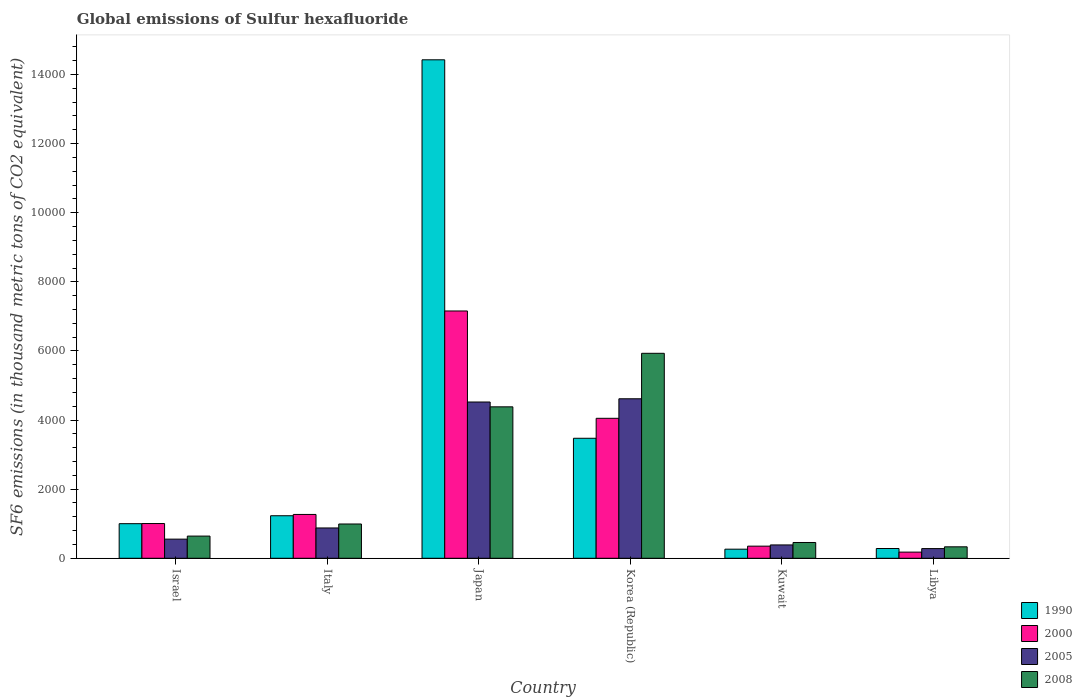How many different coloured bars are there?
Your answer should be compact. 4. How many groups of bars are there?
Give a very brief answer. 6. Are the number of bars per tick equal to the number of legend labels?
Give a very brief answer. Yes. Are the number of bars on each tick of the X-axis equal?
Offer a terse response. Yes. How many bars are there on the 1st tick from the left?
Your answer should be very brief. 4. What is the label of the 5th group of bars from the left?
Provide a short and direct response. Kuwait. What is the global emissions of Sulfur hexafluoride in 2000 in Japan?
Keep it short and to the point. 7156.6. Across all countries, what is the maximum global emissions of Sulfur hexafluoride in 2008?
Offer a very short reply. 5931.6. Across all countries, what is the minimum global emissions of Sulfur hexafluoride in 1990?
Provide a short and direct response. 263. In which country was the global emissions of Sulfur hexafluoride in 1990 minimum?
Ensure brevity in your answer.  Kuwait. What is the total global emissions of Sulfur hexafluoride in 2008 in the graph?
Give a very brief answer. 1.27e+04. What is the difference between the global emissions of Sulfur hexafluoride in 1990 in Israel and that in Japan?
Provide a succinct answer. -1.34e+04. What is the difference between the global emissions of Sulfur hexafluoride in 2005 in Japan and the global emissions of Sulfur hexafluoride in 2008 in Kuwait?
Your response must be concise. 4065.9. What is the average global emissions of Sulfur hexafluoride in 2008 per country?
Provide a short and direct response. 2122.72. What is the difference between the global emissions of Sulfur hexafluoride of/in 2000 and global emissions of Sulfur hexafluoride of/in 1990 in Korea (Republic)?
Offer a terse response. 577.6. In how many countries, is the global emissions of Sulfur hexafluoride in 1990 greater than 7600 thousand metric tons?
Provide a succinct answer. 1. What is the ratio of the global emissions of Sulfur hexafluoride in 2008 in Italy to that in Libya?
Offer a very short reply. 2.99. Is the difference between the global emissions of Sulfur hexafluoride in 2000 in Japan and Korea (Republic) greater than the difference between the global emissions of Sulfur hexafluoride in 1990 in Japan and Korea (Republic)?
Your response must be concise. No. What is the difference between the highest and the second highest global emissions of Sulfur hexafluoride in 2000?
Your answer should be very brief. -3106.1. What is the difference between the highest and the lowest global emissions of Sulfur hexafluoride in 2008?
Your answer should be compact. 5600.1. In how many countries, is the global emissions of Sulfur hexafluoride in 2000 greater than the average global emissions of Sulfur hexafluoride in 2000 taken over all countries?
Make the answer very short. 2. Is the sum of the global emissions of Sulfur hexafluoride in 2000 in Israel and Japan greater than the maximum global emissions of Sulfur hexafluoride in 2008 across all countries?
Provide a succinct answer. Yes. Is it the case that in every country, the sum of the global emissions of Sulfur hexafluoride in 1990 and global emissions of Sulfur hexafluoride in 2008 is greater than the sum of global emissions of Sulfur hexafluoride in 2005 and global emissions of Sulfur hexafluoride in 2000?
Offer a very short reply. No. What does the 3rd bar from the left in Italy represents?
Provide a short and direct response. 2005. Is it the case that in every country, the sum of the global emissions of Sulfur hexafluoride in 2000 and global emissions of Sulfur hexafluoride in 2008 is greater than the global emissions of Sulfur hexafluoride in 1990?
Offer a terse response. No. How many countries are there in the graph?
Give a very brief answer. 6. Are the values on the major ticks of Y-axis written in scientific E-notation?
Ensure brevity in your answer.  No. Where does the legend appear in the graph?
Give a very brief answer. Bottom right. How many legend labels are there?
Ensure brevity in your answer.  4. What is the title of the graph?
Provide a succinct answer. Global emissions of Sulfur hexafluoride. Does "1981" appear as one of the legend labels in the graph?
Your answer should be compact. No. What is the label or title of the X-axis?
Your answer should be very brief. Country. What is the label or title of the Y-axis?
Keep it short and to the point. SF6 emissions (in thousand metric tons of CO2 equivalent). What is the SF6 emissions (in thousand metric tons of CO2 equivalent) of 1990 in Israel?
Make the answer very short. 1001. What is the SF6 emissions (in thousand metric tons of CO2 equivalent) of 2000 in Israel?
Keep it short and to the point. 1005.2. What is the SF6 emissions (in thousand metric tons of CO2 equivalent) in 2005 in Israel?
Provide a succinct answer. 553.7. What is the SF6 emissions (in thousand metric tons of CO2 equivalent) in 2008 in Israel?
Make the answer very short. 642. What is the SF6 emissions (in thousand metric tons of CO2 equivalent) of 1990 in Italy?
Offer a very short reply. 1230.8. What is the SF6 emissions (in thousand metric tons of CO2 equivalent) in 2000 in Italy?
Your response must be concise. 1268.5. What is the SF6 emissions (in thousand metric tons of CO2 equivalent) in 2005 in Italy?
Offer a very short reply. 877.2. What is the SF6 emissions (in thousand metric tons of CO2 equivalent) of 2008 in Italy?
Ensure brevity in your answer.  992.1. What is the SF6 emissions (in thousand metric tons of CO2 equivalent) of 1990 in Japan?
Offer a very short reply. 1.44e+04. What is the SF6 emissions (in thousand metric tons of CO2 equivalent) of 2000 in Japan?
Your answer should be very brief. 7156.6. What is the SF6 emissions (in thousand metric tons of CO2 equivalent) of 2005 in Japan?
Keep it short and to the point. 4522.3. What is the SF6 emissions (in thousand metric tons of CO2 equivalent) in 2008 in Japan?
Your response must be concise. 4382.7. What is the SF6 emissions (in thousand metric tons of CO2 equivalent) of 1990 in Korea (Republic)?
Your response must be concise. 3472.9. What is the SF6 emissions (in thousand metric tons of CO2 equivalent) in 2000 in Korea (Republic)?
Offer a terse response. 4050.5. What is the SF6 emissions (in thousand metric tons of CO2 equivalent) of 2005 in Korea (Republic)?
Keep it short and to the point. 4615.7. What is the SF6 emissions (in thousand metric tons of CO2 equivalent) of 2008 in Korea (Republic)?
Ensure brevity in your answer.  5931.6. What is the SF6 emissions (in thousand metric tons of CO2 equivalent) of 1990 in Kuwait?
Ensure brevity in your answer.  263. What is the SF6 emissions (in thousand metric tons of CO2 equivalent) in 2000 in Kuwait?
Your response must be concise. 350.9. What is the SF6 emissions (in thousand metric tons of CO2 equivalent) in 2005 in Kuwait?
Give a very brief answer. 386. What is the SF6 emissions (in thousand metric tons of CO2 equivalent) in 2008 in Kuwait?
Make the answer very short. 456.4. What is the SF6 emissions (in thousand metric tons of CO2 equivalent) of 1990 in Libya?
Give a very brief answer. 282.4. What is the SF6 emissions (in thousand metric tons of CO2 equivalent) in 2000 in Libya?
Provide a succinct answer. 178.2. What is the SF6 emissions (in thousand metric tons of CO2 equivalent) in 2005 in Libya?
Make the answer very short. 280.3. What is the SF6 emissions (in thousand metric tons of CO2 equivalent) in 2008 in Libya?
Give a very brief answer. 331.5. Across all countries, what is the maximum SF6 emissions (in thousand metric tons of CO2 equivalent) in 1990?
Offer a terse response. 1.44e+04. Across all countries, what is the maximum SF6 emissions (in thousand metric tons of CO2 equivalent) of 2000?
Provide a succinct answer. 7156.6. Across all countries, what is the maximum SF6 emissions (in thousand metric tons of CO2 equivalent) of 2005?
Your answer should be very brief. 4615.7. Across all countries, what is the maximum SF6 emissions (in thousand metric tons of CO2 equivalent) in 2008?
Your answer should be compact. 5931.6. Across all countries, what is the minimum SF6 emissions (in thousand metric tons of CO2 equivalent) in 1990?
Keep it short and to the point. 263. Across all countries, what is the minimum SF6 emissions (in thousand metric tons of CO2 equivalent) in 2000?
Provide a short and direct response. 178.2. Across all countries, what is the minimum SF6 emissions (in thousand metric tons of CO2 equivalent) in 2005?
Provide a short and direct response. 280.3. Across all countries, what is the minimum SF6 emissions (in thousand metric tons of CO2 equivalent) of 2008?
Keep it short and to the point. 331.5. What is the total SF6 emissions (in thousand metric tons of CO2 equivalent) in 1990 in the graph?
Your response must be concise. 2.07e+04. What is the total SF6 emissions (in thousand metric tons of CO2 equivalent) in 2000 in the graph?
Make the answer very short. 1.40e+04. What is the total SF6 emissions (in thousand metric tons of CO2 equivalent) of 2005 in the graph?
Make the answer very short. 1.12e+04. What is the total SF6 emissions (in thousand metric tons of CO2 equivalent) of 2008 in the graph?
Ensure brevity in your answer.  1.27e+04. What is the difference between the SF6 emissions (in thousand metric tons of CO2 equivalent) in 1990 in Israel and that in Italy?
Give a very brief answer. -229.8. What is the difference between the SF6 emissions (in thousand metric tons of CO2 equivalent) in 2000 in Israel and that in Italy?
Your answer should be very brief. -263.3. What is the difference between the SF6 emissions (in thousand metric tons of CO2 equivalent) in 2005 in Israel and that in Italy?
Provide a short and direct response. -323.5. What is the difference between the SF6 emissions (in thousand metric tons of CO2 equivalent) in 2008 in Israel and that in Italy?
Make the answer very short. -350.1. What is the difference between the SF6 emissions (in thousand metric tons of CO2 equivalent) of 1990 in Israel and that in Japan?
Offer a very short reply. -1.34e+04. What is the difference between the SF6 emissions (in thousand metric tons of CO2 equivalent) of 2000 in Israel and that in Japan?
Offer a very short reply. -6151.4. What is the difference between the SF6 emissions (in thousand metric tons of CO2 equivalent) of 2005 in Israel and that in Japan?
Provide a short and direct response. -3968.6. What is the difference between the SF6 emissions (in thousand metric tons of CO2 equivalent) of 2008 in Israel and that in Japan?
Offer a terse response. -3740.7. What is the difference between the SF6 emissions (in thousand metric tons of CO2 equivalent) of 1990 in Israel and that in Korea (Republic)?
Offer a very short reply. -2471.9. What is the difference between the SF6 emissions (in thousand metric tons of CO2 equivalent) in 2000 in Israel and that in Korea (Republic)?
Provide a short and direct response. -3045.3. What is the difference between the SF6 emissions (in thousand metric tons of CO2 equivalent) of 2005 in Israel and that in Korea (Republic)?
Keep it short and to the point. -4062. What is the difference between the SF6 emissions (in thousand metric tons of CO2 equivalent) in 2008 in Israel and that in Korea (Republic)?
Offer a terse response. -5289.6. What is the difference between the SF6 emissions (in thousand metric tons of CO2 equivalent) in 1990 in Israel and that in Kuwait?
Your response must be concise. 738. What is the difference between the SF6 emissions (in thousand metric tons of CO2 equivalent) of 2000 in Israel and that in Kuwait?
Ensure brevity in your answer.  654.3. What is the difference between the SF6 emissions (in thousand metric tons of CO2 equivalent) in 2005 in Israel and that in Kuwait?
Provide a short and direct response. 167.7. What is the difference between the SF6 emissions (in thousand metric tons of CO2 equivalent) in 2008 in Israel and that in Kuwait?
Your answer should be compact. 185.6. What is the difference between the SF6 emissions (in thousand metric tons of CO2 equivalent) in 1990 in Israel and that in Libya?
Your response must be concise. 718.6. What is the difference between the SF6 emissions (in thousand metric tons of CO2 equivalent) in 2000 in Israel and that in Libya?
Make the answer very short. 827. What is the difference between the SF6 emissions (in thousand metric tons of CO2 equivalent) in 2005 in Israel and that in Libya?
Your response must be concise. 273.4. What is the difference between the SF6 emissions (in thousand metric tons of CO2 equivalent) of 2008 in Israel and that in Libya?
Your answer should be compact. 310.5. What is the difference between the SF6 emissions (in thousand metric tons of CO2 equivalent) of 1990 in Italy and that in Japan?
Keep it short and to the point. -1.32e+04. What is the difference between the SF6 emissions (in thousand metric tons of CO2 equivalent) in 2000 in Italy and that in Japan?
Give a very brief answer. -5888.1. What is the difference between the SF6 emissions (in thousand metric tons of CO2 equivalent) of 2005 in Italy and that in Japan?
Your answer should be very brief. -3645.1. What is the difference between the SF6 emissions (in thousand metric tons of CO2 equivalent) in 2008 in Italy and that in Japan?
Give a very brief answer. -3390.6. What is the difference between the SF6 emissions (in thousand metric tons of CO2 equivalent) in 1990 in Italy and that in Korea (Republic)?
Your answer should be compact. -2242.1. What is the difference between the SF6 emissions (in thousand metric tons of CO2 equivalent) in 2000 in Italy and that in Korea (Republic)?
Your answer should be compact. -2782. What is the difference between the SF6 emissions (in thousand metric tons of CO2 equivalent) in 2005 in Italy and that in Korea (Republic)?
Your response must be concise. -3738.5. What is the difference between the SF6 emissions (in thousand metric tons of CO2 equivalent) in 2008 in Italy and that in Korea (Republic)?
Ensure brevity in your answer.  -4939.5. What is the difference between the SF6 emissions (in thousand metric tons of CO2 equivalent) of 1990 in Italy and that in Kuwait?
Your answer should be compact. 967.8. What is the difference between the SF6 emissions (in thousand metric tons of CO2 equivalent) in 2000 in Italy and that in Kuwait?
Your answer should be compact. 917.6. What is the difference between the SF6 emissions (in thousand metric tons of CO2 equivalent) in 2005 in Italy and that in Kuwait?
Offer a terse response. 491.2. What is the difference between the SF6 emissions (in thousand metric tons of CO2 equivalent) of 2008 in Italy and that in Kuwait?
Provide a short and direct response. 535.7. What is the difference between the SF6 emissions (in thousand metric tons of CO2 equivalent) of 1990 in Italy and that in Libya?
Provide a short and direct response. 948.4. What is the difference between the SF6 emissions (in thousand metric tons of CO2 equivalent) in 2000 in Italy and that in Libya?
Offer a terse response. 1090.3. What is the difference between the SF6 emissions (in thousand metric tons of CO2 equivalent) in 2005 in Italy and that in Libya?
Make the answer very short. 596.9. What is the difference between the SF6 emissions (in thousand metric tons of CO2 equivalent) in 2008 in Italy and that in Libya?
Your answer should be very brief. 660.6. What is the difference between the SF6 emissions (in thousand metric tons of CO2 equivalent) in 1990 in Japan and that in Korea (Republic)?
Provide a short and direct response. 1.10e+04. What is the difference between the SF6 emissions (in thousand metric tons of CO2 equivalent) of 2000 in Japan and that in Korea (Republic)?
Make the answer very short. 3106.1. What is the difference between the SF6 emissions (in thousand metric tons of CO2 equivalent) in 2005 in Japan and that in Korea (Republic)?
Provide a succinct answer. -93.4. What is the difference between the SF6 emissions (in thousand metric tons of CO2 equivalent) in 2008 in Japan and that in Korea (Republic)?
Your response must be concise. -1548.9. What is the difference between the SF6 emissions (in thousand metric tons of CO2 equivalent) of 1990 in Japan and that in Kuwait?
Keep it short and to the point. 1.42e+04. What is the difference between the SF6 emissions (in thousand metric tons of CO2 equivalent) of 2000 in Japan and that in Kuwait?
Your response must be concise. 6805.7. What is the difference between the SF6 emissions (in thousand metric tons of CO2 equivalent) in 2005 in Japan and that in Kuwait?
Your response must be concise. 4136.3. What is the difference between the SF6 emissions (in thousand metric tons of CO2 equivalent) of 2008 in Japan and that in Kuwait?
Offer a very short reply. 3926.3. What is the difference between the SF6 emissions (in thousand metric tons of CO2 equivalent) in 1990 in Japan and that in Libya?
Make the answer very short. 1.41e+04. What is the difference between the SF6 emissions (in thousand metric tons of CO2 equivalent) in 2000 in Japan and that in Libya?
Offer a very short reply. 6978.4. What is the difference between the SF6 emissions (in thousand metric tons of CO2 equivalent) of 2005 in Japan and that in Libya?
Your response must be concise. 4242. What is the difference between the SF6 emissions (in thousand metric tons of CO2 equivalent) in 2008 in Japan and that in Libya?
Provide a short and direct response. 4051.2. What is the difference between the SF6 emissions (in thousand metric tons of CO2 equivalent) in 1990 in Korea (Republic) and that in Kuwait?
Offer a terse response. 3209.9. What is the difference between the SF6 emissions (in thousand metric tons of CO2 equivalent) of 2000 in Korea (Republic) and that in Kuwait?
Your answer should be compact. 3699.6. What is the difference between the SF6 emissions (in thousand metric tons of CO2 equivalent) of 2005 in Korea (Republic) and that in Kuwait?
Your response must be concise. 4229.7. What is the difference between the SF6 emissions (in thousand metric tons of CO2 equivalent) in 2008 in Korea (Republic) and that in Kuwait?
Your response must be concise. 5475.2. What is the difference between the SF6 emissions (in thousand metric tons of CO2 equivalent) in 1990 in Korea (Republic) and that in Libya?
Provide a succinct answer. 3190.5. What is the difference between the SF6 emissions (in thousand metric tons of CO2 equivalent) in 2000 in Korea (Republic) and that in Libya?
Keep it short and to the point. 3872.3. What is the difference between the SF6 emissions (in thousand metric tons of CO2 equivalent) of 2005 in Korea (Republic) and that in Libya?
Make the answer very short. 4335.4. What is the difference between the SF6 emissions (in thousand metric tons of CO2 equivalent) in 2008 in Korea (Republic) and that in Libya?
Make the answer very short. 5600.1. What is the difference between the SF6 emissions (in thousand metric tons of CO2 equivalent) in 1990 in Kuwait and that in Libya?
Provide a short and direct response. -19.4. What is the difference between the SF6 emissions (in thousand metric tons of CO2 equivalent) of 2000 in Kuwait and that in Libya?
Ensure brevity in your answer.  172.7. What is the difference between the SF6 emissions (in thousand metric tons of CO2 equivalent) of 2005 in Kuwait and that in Libya?
Provide a short and direct response. 105.7. What is the difference between the SF6 emissions (in thousand metric tons of CO2 equivalent) in 2008 in Kuwait and that in Libya?
Provide a succinct answer. 124.9. What is the difference between the SF6 emissions (in thousand metric tons of CO2 equivalent) in 1990 in Israel and the SF6 emissions (in thousand metric tons of CO2 equivalent) in 2000 in Italy?
Your answer should be compact. -267.5. What is the difference between the SF6 emissions (in thousand metric tons of CO2 equivalent) in 1990 in Israel and the SF6 emissions (in thousand metric tons of CO2 equivalent) in 2005 in Italy?
Provide a succinct answer. 123.8. What is the difference between the SF6 emissions (in thousand metric tons of CO2 equivalent) in 1990 in Israel and the SF6 emissions (in thousand metric tons of CO2 equivalent) in 2008 in Italy?
Ensure brevity in your answer.  8.9. What is the difference between the SF6 emissions (in thousand metric tons of CO2 equivalent) of 2000 in Israel and the SF6 emissions (in thousand metric tons of CO2 equivalent) of 2005 in Italy?
Make the answer very short. 128. What is the difference between the SF6 emissions (in thousand metric tons of CO2 equivalent) of 2000 in Israel and the SF6 emissions (in thousand metric tons of CO2 equivalent) of 2008 in Italy?
Offer a terse response. 13.1. What is the difference between the SF6 emissions (in thousand metric tons of CO2 equivalent) in 2005 in Israel and the SF6 emissions (in thousand metric tons of CO2 equivalent) in 2008 in Italy?
Offer a terse response. -438.4. What is the difference between the SF6 emissions (in thousand metric tons of CO2 equivalent) of 1990 in Israel and the SF6 emissions (in thousand metric tons of CO2 equivalent) of 2000 in Japan?
Your answer should be very brief. -6155.6. What is the difference between the SF6 emissions (in thousand metric tons of CO2 equivalent) in 1990 in Israel and the SF6 emissions (in thousand metric tons of CO2 equivalent) in 2005 in Japan?
Make the answer very short. -3521.3. What is the difference between the SF6 emissions (in thousand metric tons of CO2 equivalent) in 1990 in Israel and the SF6 emissions (in thousand metric tons of CO2 equivalent) in 2008 in Japan?
Give a very brief answer. -3381.7. What is the difference between the SF6 emissions (in thousand metric tons of CO2 equivalent) of 2000 in Israel and the SF6 emissions (in thousand metric tons of CO2 equivalent) of 2005 in Japan?
Offer a very short reply. -3517.1. What is the difference between the SF6 emissions (in thousand metric tons of CO2 equivalent) of 2000 in Israel and the SF6 emissions (in thousand metric tons of CO2 equivalent) of 2008 in Japan?
Provide a succinct answer. -3377.5. What is the difference between the SF6 emissions (in thousand metric tons of CO2 equivalent) of 2005 in Israel and the SF6 emissions (in thousand metric tons of CO2 equivalent) of 2008 in Japan?
Offer a very short reply. -3829. What is the difference between the SF6 emissions (in thousand metric tons of CO2 equivalent) of 1990 in Israel and the SF6 emissions (in thousand metric tons of CO2 equivalent) of 2000 in Korea (Republic)?
Ensure brevity in your answer.  -3049.5. What is the difference between the SF6 emissions (in thousand metric tons of CO2 equivalent) of 1990 in Israel and the SF6 emissions (in thousand metric tons of CO2 equivalent) of 2005 in Korea (Republic)?
Give a very brief answer. -3614.7. What is the difference between the SF6 emissions (in thousand metric tons of CO2 equivalent) in 1990 in Israel and the SF6 emissions (in thousand metric tons of CO2 equivalent) in 2008 in Korea (Republic)?
Keep it short and to the point. -4930.6. What is the difference between the SF6 emissions (in thousand metric tons of CO2 equivalent) of 2000 in Israel and the SF6 emissions (in thousand metric tons of CO2 equivalent) of 2005 in Korea (Republic)?
Offer a terse response. -3610.5. What is the difference between the SF6 emissions (in thousand metric tons of CO2 equivalent) of 2000 in Israel and the SF6 emissions (in thousand metric tons of CO2 equivalent) of 2008 in Korea (Republic)?
Your response must be concise. -4926.4. What is the difference between the SF6 emissions (in thousand metric tons of CO2 equivalent) of 2005 in Israel and the SF6 emissions (in thousand metric tons of CO2 equivalent) of 2008 in Korea (Republic)?
Your answer should be compact. -5377.9. What is the difference between the SF6 emissions (in thousand metric tons of CO2 equivalent) of 1990 in Israel and the SF6 emissions (in thousand metric tons of CO2 equivalent) of 2000 in Kuwait?
Make the answer very short. 650.1. What is the difference between the SF6 emissions (in thousand metric tons of CO2 equivalent) in 1990 in Israel and the SF6 emissions (in thousand metric tons of CO2 equivalent) in 2005 in Kuwait?
Make the answer very short. 615. What is the difference between the SF6 emissions (in thousand metric tons of CO2 equivalent) in 1990 in Israel and the SF6 emissions (in thousand metric tons of CO2 equivalent) in 2008 in Kuwait?
Provide a short and direct response. 544.6. What is the difference between the SF6 emissions (in thousand metric tons of CO2 equivalent) of 2000 in Israel and the SF6 emissions (in thousand metric tons of CO2 equivalent) of 2005 in Kuwait?
Your answer should be compact. 619.2. What is the difference between the SF6 emissions (in thousand metric tons of CO2 equivalent) in 2000 in Israel and the SF6 emissions (in thousand metric tons of CO2 equivalent) in 2008 in Kuwait?
Keep it short and to the point. 548.8. What is the difference between the SF6 emissions (in thousand metric tons of CO2 equivalent) in 2005 in Israel and the SF6 emissions (in thousand metric tons of CO2 equivalent) in 2008 in Kuwait?
Your answer should be compact. 97.3. What is the difference between the SF6 emissions (in thousand metric tons of CO2 equivalent) of 1990 in Israel and the SF6 emissions (in thousand metric tons of CO2 equivalent) of 2000 in Libya?
Provide a short and direct response. 822.8. What is the difference between the SF6 emissions (in thousand metric tons of CO2 equivalent) in 1990 in Israel and the SF6 emissions (in thousand metric tons of CO2 equivalent) in 2005 in Libya?
Offer a terse response. 720.7. What is the difference between the SF6 emissions (in thousand metric tons of CO2 equivalent) in 1990 in Israel and the SF6 emissions (in thousand metric tons of CO2 equivalent) in 2008 in Libya?
Provide a short and direct response. 669.5. What is the difference between the SF6 emissions (in thousand metric tons of CO2 equivalent) in 2000 in Israel and the SF6 emissions (in thousand metric tons of CO2 equivalent) in 2005 in Libya?
Provide a succinct answer. 724.9. What is the difference between the SF6 emissions (in thousand metric tons of CO2 equivalent) in 2000 in Israel and the SF6 emissions (in thousand metric tons of CO2 equivalent) in 2008 in Libya?
Your answer should be compact. 673.7. What is the difference between the SF6 emissions (in thousand metric tons of CO2 equivalent) of 2005 in Israel and the SF6 emissions (in thousand metric tons of CO2 equivalent) of 2008 in Libya?
Your response must be concise. 222.2. What is the difference between the SF6 emissions (in thousand metric tons of CO2 equivalent) of 1990 in Italy and the SF6 emissions (in thousand metric tons of CO2 equivalent) of 2000 in Japan?
Offer a terse response. -5925.8. What is the difference between the SF6 emissions (in thousand metric tons of CO2 equivalent) in 1990 in Italy and the SF6 emissions (in thousand metric tons of CO2 equivalent) in 2005 in Japan?
Provide a succinct answer. -3291.5. What is the difference between the SF6 emissions (in thousand metric tons of CO2 equivalent) in 1990 in Italy and the SF6 emissions (in thousand metric tons of CO2 equivalent) in 2008 in Japan?
Keep it short and to the point. -3151.9. What is the difference between the SF6 emissions (in thousand metric tons of CO2 equivalent) in 2000 in Italy and the SF6 emissions (in thousand metric tons of CO2 equivalent) in 2005 in Japan?
Offer a terse response. -3253.8. What is the difference between the SF6 emissions (in thousand metric tons of CO2 equivalent) of 2000 in Italy and the SF6 emissions (in thousand metric tons of CO2 equivalent) of 2008 in Japan?
Offer a very short reply. -3114.2. What is the difference between the SF6 emissions (in thousand metric tons of CO2 equivalent) of 2005 in Italy and the SF6 emissions (in thousand metric tons of CO2 equivalent) of 2008 in Japan?
Your response must be concise. -3505.5. What is the difference between the SF6 emissions (in thousand metric tons of CO2 equivalent) of 1990 in Italy and the SF6 emissions (in thousand metric tons of CO2 equivalent) of 2000 in Korea (Republic)?
Provide a succinct answer. -2819.7. What is the difference between the SF6 emissions (in thousand metric tons of CO2 equivalent) in 1990 in Italy and the SF6 emissions (in thousand metric tons of CO2 equivalent) in 2005 in Korea (Republic)?
Make the answer very short. -3384.9. What is the difference between the SF6 emissions (in thousand metric tons of CO2 equivalent) in 1990 in Italy and the SF6 emissions (in thousand metric tons of CO2 equivalent) in 2008 in Korea (Republic)?
Your answer should be very brief. -4700.8. What is the difference between the SF6 emissions (in thousand metric tons of CO2 equivalent) of 2000 in Italy and the SF6 emissions (in thousand metric tons of CO2 equivalent) of 2005 in Korea (Republic)?
Provide a succinct answer. -3347.2. What is the difference between the SF6 emissions (in thousand metric tons of CO2 equivalent) in 2000 in Italy and the SF6 emissions (in thousand metric tons of CO2 equivalent) in 2008 in Korea (Republic)?
Make the answer very short. -4663.1. What is the difference between the SF6 emissions (in thousand metric tons of CO2 equivalent) of 2005 in Italy and the SF6 emissions (in thousand metric tons of CO2 equivalent) of 2008 in Korea (Republic)?
Ensure brevity in your answer.  -5054.4. What is the difference between the SF6 emissions (in thousand metric tons of CO2 equivalent) of 1990 in Italy and the SF6 emissions (in thousand metric tons of CO2 equivalent) of 2000 in Kuwait?
Make the answer very short. 879.9. What is the difference between the SF6 emissions (in thousand metric tons of CO2 equivalent) in 1990 in Italy and the SF6 emissions (in thousand metric tons of CO2 equivalent) in 2005 in Kuwait?
Provide a succinct answer. 844.8. What is the difference between the SF6 emissions (in thousand metric tons of CO2 equivalent) in 1990 in Italy and the SF6 emissions (in thousand metric tons of CO2 equivalent) in 2008 in Kuwait?
Offer a terse response. 774.4. What is the difference between the SF6 emissions (in thousand metric tons of CO2 equivalent) in 2000 in Italy and the SF6 emissions (in thousand metric tons of CO2 equivalent) in 2005 in Kuwait?
Keep it short and to the point. 882.5. What is the difference between the SF6 emissions (in thousand metric tons of CO2 equivalent) in 2000 in Italy and the SF6 emissions (in thousand metric tons of CO2 equivalent) in 2008 in Kuwait?
Provide a succinct answer. 812.1. What is the difference between the SF6 emissions (in thousand metric tons of CO2 equivalent) in 2005 in Italy and the SF6 emissions (in thousand metric tons of CO2 equivalent) in 2008 in Kuwait?
Your answer should be compact. 420.8. What is the difference between the SF6 emissions (in thousand metric tons of CO2 equivalent) in 1990 in Italy and the SF6 emissions (in thousand metric tons of CO2 equivalent) in 2000 in Libya?
Keep it short and to the point. 1052.6. What is the difference between the SF6 emissions (in thousand metric tons of CO2 equivalent) of 1990 in Italy and the SF6 emissions (in thousand metric tons of CO2 equivalent) of 2005 in Libya?
Keep it short and to the point. 950.5. What is the difference between the SF6 emissions (in thousand metric tons of CO2 equivalent) in 1990 in Italy and the SF6 emissions (in thousand metric tons of CO2 equivalent) in 2008 in Libya?
Ensure brevity in your answer.  899.3. What is the difference between the SF6 emissions (in thousand metric tons of CO2 equivalent) of 2000 in Italy and the SF6 emissions (in thousand metric tons of CO2 equivalent) of 2005 in Libya?
Offer a very short reply. 988.2. What is the difference between the SF6 emissions (in thousand metric tons of CO2 equivalent) in 2000 in Italy and the SF6 emissions (in thousand metric tons of CO2 equivalent) in 2008 in Libya?
Provide a succinct answer. 937. What is the difference between the SF6 emissions (in thousand metric tons of CO2 equivalent) in 2005 in Italy and the SF6 emissions (in thousand metric tons of CO2 equivalent) in 2008 in Libya?
Your answer should be very brief. 545.7. What is the difference between the SF6 emissions (in thousand metric tons of CO2 equivalent) in 1990 in Japan and the SF6 emissions (in thousand metric tons of CO2 equivalent) in 2000 in Korea (Republic)?
Ensure brevity in your answer.  1.04e+04. What is the difference between the SF6 emissions (in thousand metric tons of CO2 equivalent) of 1990 in Japan and the SF6 emissions (in thousand metric tons of CO2 equivalent) of 2005 in Korea (Republic)?
Offer a very short reply. 9810.1. What is the difference between the SF6 emissions (in thousand metric tons of CO2 equivalent) of 1990 in Japan and the SF6 emissions (in thousand metric tons of CO2 equivalent) of 2008 in Korea (Republic)?
Offer a very short reply. 8494.2. What is the difference between the SF6 emissions (in thousand metric tons of CO2 equivalent) in 2000 in Japan and the SF6 emissions (in thousand metric tons of CO2 equivalent) in 2005 in Korea (Republic)?
Give a very brief answer. 2540.9. What is the difference between the SF6 emissions (in thousand metric tons of CO2 equivalent) of 2000 in Japan and the SF6 emissions (in thousand metric tons of CO2 equivalent) of 2008 in Korea (Republic)?
Your answer should be compact. 1225. What is the difference between the SF6 emissions (in thousand metric tons of CO2 equivalent) in 2005 in Japan and the SF6 emissions (in thousand metric tons of CO2 equivalent) in 2008 in Korea (Republic)?
Your answer should be very brief. -1409.3. What is the difference between the SF6 emissions (in thousand metric tons of CO2 equivalent) in 1990 in Japan and the SF6 emissions (in thousand metric tons of CO2 equivalent) in 2000 in Kuwait?
Provide a succinct answer. 1.41e+04. What is the difference between the SF6 emissions (in thousand metric tons of CO2 equivalent) of 1990 in Japan and the SF6 emissions (in thousand metric tons of CO2 equivalent) of 2005 in Kuwait?
Offer a terse response. 1.40e+04. What is the difference between the SF6 emissions (in thousand metric tons of CO2 equivalent) in 1990 in Japan and the SF6 emissions (in thousand metric tons of CO2 equivalent) in 2008 in Kuwait?
Offer a very short reply. 1.40e+04. What is the difference between the SF6 emissions (in thousand metric tons of CO2 equivalent) of 2000 in Japan and the SF6 emissions (in thousand metric tons of CO2 equivalent) of 2005 in Kuwait?
Offer a very short reply. 6770.6. What is the difference between the SF6 emissions (in thousand metric tons of CO2 equivalent) of 2000 in Japan and the SF6 emissions (in thousand metric tons of CO2 equivalent) of 2008 in Kuwait?
Keep it short and to the point. 6700.2. What is the difference between the SF6 emissions (in thousand metric tons of CO2 equivalent) in 2005 in Japan and the SF6 emissions (in thousand metric tons of CO2 equivalent) in 2008 in Kuwait?
Your answer should be very brief. 4065.9. What is the difference between the SF6 emissions (in thousand metric tons of CO2 equivalent) in 1990 in Japan and the SF6 emissions (in thousand metric tons of CO2 equivalent) in 2000 in Libya?
Offer a very short reply. 1.42e+04. What is the difference between the SF6 emissions (in thousand metric tons of CO2 equivalent) in 1990 in Japan and the SF6 emissions (in thousand metric tons of CO2 equivalent) in 2005 in Libya?
Your answer should be compact. 1.41e+04. What is the difference between the SF6 emissions (in thousand metric tons of CO2 equivalent) in 1990 in Japan and the SF6 emissions (in thousand metric tons of CO2 equivalent) in 2008 in Libya?
Provide a short and direct response. 1.41e+04. What is the difference between the SF6 emissions (in thousand metric tons of CO2 equivalent) of 2000 in Japan and the SF6 emissions (in thousand metric tons of CO2 equivalent) of 2005 in Libya?
Ensure brevity in your answer.  6876.3. What is the difference between the SF6 emissions (in thousand metric tons of CO2 equivalent) of 2000 in Japan and the SF6 emissions (in thousand metric tons of CO2 equivalent) of 2008 in Libya?
Your response must be concise. 6825.1. What is the difference between the SF6 emissions (in thousand metric tons of CO2 equivalent) in 2005 in Japan and the SF6 emissions (in thousand metric tons of CO2 equivalent) in 2008 in Libya?
Give a very brief answer. 4190.8. What is the difference between the SF6 emissions (in thousand metric tons of CO2 equivalent) of 1990 in Korea (Republic) and the SF6 emissions (in thousand metric tons of CO2 equivalent) of 2000 in Kuwait?
Keep it short and to the point. 3122. What is the difference between the SF6 emissions (in thousand metric tons of CO2 equivalent) in 1990 in Korea (Republic) and the SF6 emissions (in thousand metric tons of CO2 equivalent) in 2005 in Kuwait?
Provide a short and direct response. 3086.9. What is the difference between the SF6 emissions (in thousand metric tons of CO2 equivalent) of 1990 in Korea (Republic) and the SF6 emissions (in thousand metric tons of CO2 equivalent) of 2008 in Kuwait?
Make the answer very short. 3016.5. What is the difference between the SF6 emissions (in thousand metric tons of CO2 equivalent) of 2000 in Korea (Republic) and the SF6 emissions (in thousand metric tons of CO2 equivalent) of 2005 in Kuwait?
Keep it short and to the point. 3664.5. What is the difference between the SF6 emissions (in thousand metric tons of CO2 equivalent) of 2000 in Korea (Republic) and the SF6 emissions (in thousand metric tons of CO2 equivalent) of 2008 in Kuwait?
Offer a terse response. 3594.1. What is the difference between the SF6 emissions (in thousand metric tons of CO2 equivalent) in 2005 in Korea (Republic) and the SF6 emissions (in thousand metric tons of CO2 equivalent) in 2008 in Kuwait?
Keep it short and to the point. 4159.3. What is the difference between the SF6 emissions (in thousand metric tons of CO2 equivalent) of 1990 in Korea (Republic) and the SF6 emissions (in thousand metric tons of CO2 equivalent) of 2000 in Libya?
Ensure brevity in your answer.  3294.7. What is the difference between the SF6 emissions (in thousand metric tons of CO2 equivalent) in 1990 in Korea (Republic) and the SF6 emissions (in thousand metric tons of CO2 equivalent) in 2005 in Libya?
Your answer should be very brief. 3192.6. What is the difference between the SF6 emissions (in thousand metric tons of CO2 equivalent) in 1990 in Korea (Republic) and the SF6 emissions (in thousand metric tons of CO2 equivalent) in 2008 in Libya?
Provide a short and direct response. 3141.4. What is the difference between the SF6 emissions (in thousand metric tons of CO2 equivalent) of 2000 in Korea (Republic) and the SF6 emissions (in thousand metric tons of CO2 equivalent) of 2005 in Libya?
Provide a succinct answer. 3770.2. What is the difference between the SF6 emissions (in thousand metric tons of CO2 equivalent) in 2000 in Korea (Republic) and the SF6 emissions (in thousand metric tons of CO2 equivalent) in 2008 in Libya?
Ensure brevity in your answer.  3719. What is the difference between the SF6 emissions (in thousand metric tons of CO2 equivalent) of 2005 in Korea (Republic) and the SF6 emissions (in thousand metric tons of CO2 equivalent) of 2008 in Libya?
Give a very brief answer. 4284.2. What is the difference between the SF6 emissions (in thousand metric tons of CO2 equivalent) of 1990 in Kuwait and the SF6 emissions (in thousand metric tons of CO2 equivalent) of 2000 in Libya?
Your answer should be compact. 84.8. What is the difference between the SF6 emissions (in thousand metric tons of CO2 equivalent) of 1990 in Kuwait and the SF6 emissions (in thousand metric tons of CO2 equivalent) of 2005 in Libya?
Make the answer very short. -17.3. What is the difference between the SF6 emissions (in thousand metric tons of CO2 equivalent) in 1990 in Kuwait and the SF6 emissions (in thousand metric tons of CO2 equivalent) in 2008 in Libya?
Provide a short and direct response. -68.5. What is the difference between the SF6 emissions (in thousand metric tons of CO2 equivalent) in 2000 in Kuwait and the SF6 emissions (in thousand metric tons of CO2 equivalent) in 2005 in Libya?
Offer a terse response. 70.6. What is the difference between the SF6 emissions (in thousand metric tons of CO2 equivalent) of 2005 in Kuwait and the SF6 emissions (in thousand metric tons of CO2 equivalent) of 2008 in Libya?
Offer a very short reply. 54.5. What is the average SF6 emissions (in thousand metric tons of CO2 equivalent) in 1990 per country?
Offer a terse response. 3445.98. What is the average SF6 emissions (in thousand metric tons of CO2 equivalent) in 2000 per country?
Your answer should be very brief. 2334.98. What is the average SF6 emissions (in thousand metric tons of CO2 equivalent) of 2005 per country?
Make the answer very short. 1872.53. What is the average SF6 emissions (in thousand metric tons of CO2 equivalent) in 2008 per country?
Provide a short and direct response. 2122.72. What is the difference between the SF6 emissions (in thousand metric tons of CO2 equivalent) in 1990 and SF6 emissions (in thousand metric tons of CO2 equivalent) in 2000 in Israel?
Provide a succinct answer. -4.2. What is the difference between the SF6 emissions (in thousand metric tons of CO2 equivalent) of 1990 and SF6 emissions (in thousand metric tons of CO2 equivalent) of 2005 in Israel?
Your answer should be very brief. 447.3. What is the difference between the SF6 emissions (in thousand metric tons of CO2 equivalent) of 1990 and SF6 emissions (in thousand metric tons of CO2 equivalent) of 2008 in Israel?
Your response must be concise. 359. What is the difference between the SF6 emissions (in thousand metric tons of CO2 equivalent) of 2000 and SF6 emissions (in thousand metric tons of CO2 equivalent) of 2005 in Israel?
Ensure brevity in your answer.  451.5. What is the difference between the SF6 emissions (in thousand metric tons of CO2 equivalent) of 2000 and SF6 emissions (in thousand metric tons of CO2 equivalent) of 2008 in Israel?
Make the answer very short. 363.2. What is the difference between the SF6 emissions (in thousand metric tons of CO2 equivalent) of 2005 and SF6 emissions (in thousand metric tons of CO2 equivalent) of 2008 in Israel?
Offer a very short reply. -88.3. What is the difference between the SF6 emissions (in thousand metric tons of CO2 equivalent) of 1990 and SF6 emissions (in thousand metric tons of CO2 equivalent) of 2000 in Italy?
Provide a succinct answer. -37.7. What is the difference between the SF6 emissions (in thousand metric tons of CO2 equivalent) of 1990 and SF6 emissions (in thousand metric tons of CO2 equivalent) of 2005 in Italy?
Make the answer very short. 353.6. What is the difference between the SF6 emissions (in thousand metric tons of CO2 equivalent) of 1990 and SF6 emissions (in thousand metric tons of CO2 equivalent) of 2008 in Italy?
Offer a terse response. 238.7. What is the difference between the SF6 emissions (in thousand metric tons of CO2 equivalent) of 2000 and SF6 emissions (in thousand metric tons of CO2 equivalent) of 2005 in Italy?
Offer a very short reply. 391.3. What is the difference between the SF6 emissions (in thousand metric tons of CO2 equivalent) of 2000 and SF6 emissions (in thousand metric tons of CO2 equivalent) of 2008 in Italy?
Your answer should be very brief. 276.4. What is the difference between the SF6 emissions (in thousand metric tons of CO2 equivalent) of 2005 and SF6 emissions (in thousand metric tons of CO2 equivalent) of 2008 in Italy?
Give a very brief answer. -114.9. What is the difference between the SF6 emissions (in thousand metric tons of CO2 equivalent) of 1990 and SF6 emissions (in thousand metric tons of CO2 equivalent) of 2000 in Japan?
Your response must be concise. 7269.2. What is the difference between the SF6 emissions (in thousand metric tons of CO2 equivalent) of 1990 and SF6 emissions (in thousand metric tons of CO2 equivalent) of 2005 in Japan?
Make the answer very short. 9903.5. What is the difference between the SF6 emissions (in thousand metric tons of CO2 equivalent) in 1990 and SF6 emissions (in thousand metric tons of CO2 equivalent) in 2008 in Japan?
Provide a short and direct response. 1.00e+04. What is the difference between the SF6 emissions (in thousand metric tons of CO2 equivalent) in 2000 and SF6 emissions (in thousand metric tons of CO2 equivalent) in 2005 in Japan?
Make the answer very short. 2634.3. What is the difference between the SF6 emissions (in thousand metric tons of CO2 equivalent) in 2000 and SF6 emissions (in thousand metric tons of CO2 equivalent) in 2008 in Japan?
Your response must be concise. 2773.9. What is the difference between the SF6 emissions (in thousand metric tons of CO2 equivalent) of 2005 and SF6 emissions (in thousand metric tons of CO2 equivalent) of 2008 in Japan?
Your answer should be compact. 139.6. What is the difference between the SF6 emissions (in thousand metric tons of CO2 equivalent) in 1990 and SF6 emissions (in thousand metric tons of CO2 equivalent) in 2000 in Korea (Republic)?
Your answer should be compact. -577.6. What is the difference between the SF6 emissions (in thousand metric tons of CO2 equivalent) in 1990 and SF6 emissions (in thousand metric tons of CO2 equivalent) in 2005 in Korea (Republic)?
Keep it short and to the point. -1142.8. What is the difference between the SF6 emissions (in thousand metric tons of CO2 equivalent) in 1990 and SF6 emissions (in thousand metric tons of CO2 equivalent) in 2008 in Korea (Republic)?
Your answer should be compact. -2458.7. What is the difference between the SF6 emissions (in thousand metric tons of CO2 equivalent) of 2000 and SF6 emissions (in thousand metric tons of CO2 equivalent) of 2005 in Korea (Republic)?
Offer a very short reply. -565.2. What is the difference between the SF6 emissions (in thousand metric tons of CO2 equivalent) of 2000 and SF6 emissions (in thousand metric tons of CO2 equivalent) of 2008 in Korea (Republic)?
Give a very brief answer. -1881.1. What is the difference between the SF6 emissions (in thousand metric tons of CO2 equivalent) of 2005 and SF6 emissions (in thousand metric tons of CO2 equivalent) of 2008 in Korea (Republic)?
Your answer should be very brief. -1315.9. What is the difference between the SF6 emissions (in thousand metric tons of CO2 equivalent) of 1990 and SF6 emissions (in thousand metric tons of CO2 equivalent) of 2000 in Kuwait?
Provide a succinct answer. -87.9. What is the difference between the SF6 emissions (in thousand metric tons of CO2 equivalent) of 1990 and SF6 emissions (in thousand metric tons of CO2 equivalent) of 2005 in Kuwait?
Offer a terse response. -123. What is the difference between the SF6 emissions (in thousand metric tons of CO2 equivalent) of 1990 and SF6 emissions (in thousand metric tons of CO2 equivalent) of 2008 in Kuwait?
Keep it short and to the point. -193.4. What is the difference between the SF6 emissions (in thousand metric tons of CO2 equivalent) of 2000 and SF6 emissions (in thousand metric tons of CO2 equivalent) of 2005 in Kuwait?
Offer a very short reply. -35.1. What is the difference between the SF6 emissions (in thousand metric tons of CO2 equivalent) in 2000 and SF6 emissions (in thousand metric tons of CO2 equivalent) in 2008 in Kuwait?
Ensure brevity in your answer.  -105.5. What is the difference between the SF6 emissions (in thousand metric tons of CO2 equivalent) in 2005 and SF6 emissions (in thousand metric tons of CO2 equivalent) in 2008 in Kuwait?
Your answer should be compact. -70.4. What is the difference between the SF6 emissions (in thousand metric tons of CO2 equivalent) in 1990 and SF6 emissions (in thousand metric tons of CO2 equivalent) in 2000 in Libya?
Keep it short and to the point. 104.2. What is the difference between the SF6 emissions (in thousand metric tons of CO2 equivalent) of 1990 and SF6 emissions (in thousand metric tons of CO2 equivalent) of 2005 in Libya?
Give a very brief answer. 2.1. What is the difference between the SF6 emissions (in thousand metric tons of CO2 equivalent) of 1990 and SF6 emissions (in thousand metric tons of CO2 equivalent) of 2008 in Libya?
Provide a short and direct response. -49.1. What is the difference between the SF6 emissions (in thousand metric tons of CO2 equivalent) in 2000 and SF6 emissions (in thousand metric tons of CO2 equivalent) in 2005 in Libya?
Keep it short and to the point. -102.1. What is the difference between the SF6 emissions (in thousand metric tons of CO2 equivalent) in 2000 and SF6 emissions (in thousand metric tons of CO2 equivalent) in 2008 in Libya?
Provide a short and direct response. -153.3. What is the difference between the SF6 emissions (in thousand metric tons of CO2 equivalent) of 2005 and SF6 emissions (in thousand metric tons of CO2 equivalent) of 2008 in Libya?
Give a very brief answer. -51.2. What is the ratio of the SF6 emissions (in thousand metric tons of CO2 equivalent) of 1990 in Israel to that in Italy?
Your answer should be compact. 0.81. What is the ratio of the SF6 emissions (in thousand metric tons of CO2 equivalent) in 2000 in Israel to that in Italy?
Your response must be concise. 0.79. What is the ratio of the SF6 emissions (in thousand metric tons of CO2 equivalent) of 2005 in Israel to that in Italy?
Your answer should be compact. 0.63. What is the ratio of the SF6 emissions (in thousand metric tons of CO2 equivalent) of 2008 in Israel to that in Italy?
Make the answer very short. 0.65. What is the ratio of the SF6 emissions (in thousand metric tons of CO2 equivalent) of 1990 in Israel to that in Japan?
Give a very brief answer. 0.07. What is the ratio of the SF6 emissions (in thousand metric tons of CO2 equivalent) of 2000 in Israel to that in Japan?
Offer a very short reply. 0.14. What is the ratio of the SF6 emissions (in thousand metric tons of CO2 equivalent) of 2005 in Israel to that in Japan?
Your response must be concise. 0.12. What is the ratio of the SF6 emissions (in thousand metric tons of CO2 equivalent) in 2008 in Israel to that in Japan?
Offer a very short reply. 0.15. What is the ratio of the SF6 emissions (in thousand metric tons of CO2 equivalent) in 1990 in Israel to that in Korea (Republic)?
Your answer should be compact. 0.29. What is the ratio of the SF6 emissions (in thousand metric tons of CO2 equivalent) of 2000 in Israel to that in Korea (Republic)?
Ensure brevity in your answer.  0.25. What is the ratio of the SF6 emissions (in thousand metric tons of CO2 equivalent) of 2005 in Israel to that in Korea (Republic)?
Your answer should be compact. 0.12. What is the ratio of the SF6 emissions (in thousand metric tons of CO2 equivalent) of 2008 in Israel to that in Korea (Republic)?
Offer a terse response. 0.11. What is the ratio of the SF6 emissions (in thousand metric tons of CO2 equivalent) of 1990 in Israel to that in Kuwait?
Offer a very short reply. 3.81. What is the ratio of the SF6 emissions (in thousand metric tons of CO2 equivalent) in 2000 in Israel to that in Kuwait?
Give a very brief answer. 2.86. What is the ratio of the SF6 emissions (in thousand metric tons of CO2 equivalent) of 2005 in Israel to that in Kuwait?
Ensure brevity in your answer.  1.43. What is the ratio of the SF6 emissions (in thousand metric tons of CO2 equivalent) of 2008 in Israel to that in Kuwait?
Offer a very short reply. 1.41. What is the ratio of the SF6 emissions (in thousand metric tons of CO2 equivalent) in 1990 in Israel to that in Libya?
Keep it short and to the point. 3.54. What is the ratio of the SF6 emissions (in thousand metric tons of CO2 equivalent) of 2000 in Israel to that in Libya?
Offer a very short reply. 5.64. What is the ratio of the SF6 emissions (in thousand metric tons of CO2 equivalent) of 2005 in Israel to that in Libya?
Provide a short and direct response. 1.98. What is the ratio of the SF6 emissions (in thousand metric tons of CO2 equivalent) in 2008 in Israel to that in Libya?
Make the answer very short. 1.94. What is the ratio of the SF6 emissions (in thousand metric tons of CO2 equivalent) of 1990 in Italy to that in Japan?
Offer a terse response. 0.09. What is the ratio of the SF6 emissions (in thousand metric tons of CO2 equivalent) in 2000 in Italy to that in Japan?
Offer a very short reply. 0.18. What is the ratio of the SF6 emissions (in thousand metric tons of CO2 equivalent) of 2005 in Italy to that in Japan?
Give a very brief answer. 0.19. What is the ratio of the SF6 emissions (in thousand metric tons of CO2 equivalent) of 2008 in Italy to that in Japan?
Your answer should be compact. 0.23. What is the ratio of the SF6 emissions (in thousand metric tons of CO2 equivalent) in 1990 in Italy to that in Korea (Republic)?
Your answer should be compact. 0.35. What is the ratio of the SF6 emissions (in thousand metric tons of CO2 equivalent) of 2000 in Italy to that in Korea (Republic)?
Your answer should be compact. 0.31. What is the ratio of the SF6 emissions (in thousand metric tons of CO2 equivalent) of 2005 in Italy to that in Korea (Republic)?
Provide a succinct answer. 0.19. What is the ratio of the SF6 emissions (in thousand metric tons of CO2 equivalent) in 2008 in Italy to that in Korea (Republic)?
Offer a terse response. 0.17. What is the ratio of the SF6 emissions (in thousand metric tons of CO2 equivalent) of 1990 in Italy to that in Kuwait?
Your answer should be very brief. 4.68. What is the ratio of the SF6 emissions (in thousand metric tons of CO2 equivalent) of 2000 in Italy to that in Kuwait?
Make the answer very short. 3.62. What is the ratio of the SF6 emissions (in thousand metric tons of CO2 equivalent) of 2005 in Italy to that in Kuwait?
Provide a succinct answer. 2.27. What is the ratio of the SF6 emissions (in thousand metric tons of CO2 equivalent) of 2008 in Italy to that in Kuwait?
Keep it short and to the point. 2.17. What is the ratio of the SF6 emissions (in thousand metric tons of CO2 equivalent) of 1990 in Italy to that in Libya?
Offer a terse response. 4.36. What is the ratio of the SF6 emissions (in thousand metric tons of CO2 equivalent) of 2000 in Italy to that in Libya?
Provide a succinct answer. 7.12. What is the ratio of the SF6 emissions (in thousand metric tons of CO2 equivalent) in 2005 in Italy to that in Libya?
Provide a succinct answer. 3.13. What is the ratio of the SF6 emissions (in thousand metric tons of CO2 equivalent) of 2008 in Italy to that in Libya?
Offer a very short reply. 2.99. What is the ratio of the SF6 emissions (in thousand metric tons of CO2 equivalent) in 1990 in Japan to that in Korea (Republic)?
Keep it short and to the point. 4.15. What is the ratio of the SF6 emissions (in thousand metric tons of CO2 equivalent) of 2000 in Japan to that in Korea (Republic)?
Make the answer very short. 1.77. What is the ratio of the SF6 emissions (in thousand metric tons of CO2 equivalent) in 2005 in Japan to that in Korea (Republic)?
Give a very brief answer. 0.98. What is the ratio of the SF6 emissions (in thousand metric tons of CO2 equivalent) in 2008 in Japan to that in Korea (Republic)?
Make the answer very short. 0.74. What is the ratio of the SF6 emissions (in thousand metric tons of CO2 equivalent) in 1990 in Japan to that in Kuwait?
Give a very brief answer. 54.85. What is the ratio of the SF6 emissions (in thousand metric tons of CO2 equivalent) in 2000 in Japan to that in Kuwait?
Your answer should be compact. 20.39. What is the ratio of the SF6 emissions (in thousand metric tons of CO2 equivalent) of 2005 in Japan to that in Kuwait?
Your answer should be compact. 11.72. What is the ratio of the SF6 emissions (in thousand metric tons of CO2 equivalent) of 2008 in Japan to that in Kuwait?
Provide a succinct answer. 9.6. What is the ratio of the SF6 emissions (in thousand metric tons of CO2 equivalent) in 1990 in Japan to that in Libya?
Ensure brevity in your answer.  51.08. What is the ratio of the SF6 emissions (in thousand metric tons of CO2 equivalent) of 2000 in Japan to that in Libya?
Give a very brief answer. 40.16. What is the ratio of the SF6 emissions (in thousand metric tons of CO2 equivalent) in 2005 in Japan to that in Libya?
Your answer should be compact. 16.13. What is the ratio of the SF6 emissions (in thousand metric tons of CO2 equivalent) in 2008 in Japan to that in Libya?
Offer a terse response. 13.22. What is the ratio of the SF6 emissions (in thousand metric tons of CO2 equivalent) in 1990 in Korea (Republic) to that in Kuwait?
Make the answer very short. 13.2. What is the ratio of the SF6 emissions (in thousand metric tons of CO2 equivalent) of 2000 in Korea (Republic) to that in Kuwait?
Make the answer very short. 11.54. What is the ratio of the SF6 emissions (in thousand metric tons of CO2 equivalent) in 2005 in Korea (Republic) to that in Kuwait?
Your response must be concise. 11.96. What is the ratio of the SF6 emissions (in thousand metric tons of CO2 equivalent) in 2008 in Korea (Republic) to that in Kuwait?
Ensure brevity in your answer.  13. What is the ratio of the SF6 emissions (in thousand metric tons of CO2 equivalent) in 1990 in Korea (Republic) to that in Libya?
Make the answer very short. 12.3. What is the ratio of the SF6 emissions (in thousand metric tons of CO2 equivalent) of 2000 in Korea (Republic) to that in Libya?
Keep it short and to the point. 22.73. What is the ratio of the SF6 emissions (in thousand metric tons of CO2 equivalent) of 2005 in Korea (Republic) to that in Libya?
Provide a succinct answer. 16.47. What is the ratio of the SF6 emissions (in thousand metric tons of CO2 equivalent) of 2008 in Korea (Republic) to that in Libya?
Your response must be concise. 17.89. What is the ratio of the SF6 emissions (in thousand metric tons of CO2 equivalent) of 1990 in Kuwait to that in Libya?
Ensure brevity in your answer.  0.93. What is the ratio of the SF6 emissions (in thousand metric tons of CO2 equivalent) in 2000 in Kuwait to that in Libya?
Your response must be concise. 1.97. What is the ratio of the SF6 emissions (in thousand metric tons of CO2 equivalent) in 2005 in Kuwait to that in Libya?
Keep it short and to the point. 1.38. What is the ratio of the SF6 emissions (in thousand metric tons of CO2 equivalent) of 2008 in Kuwait to that in Libya?
Your answer should be very brief. 1.38. What is the difference between the highest and the second highest SF6 emissions (in thousand metric tons of CO2 equivalent) in 1990?
Give a very brief answer. 1.10e+04. What is the difference between the highest and the second highest SF6 emissions (in thousand metric tons of CO2 equivalent) of 2000?
Ensure brevity in your answer.  3106.1. What is the difference between the highest and the second highest SF6 emissions (in thousand metric tons of CO2 equivalent) in 2005?
Make the answer very short. 93.4. What is the difference between the highest and the second highest SF6 emissions (in thousand metric tons of CO2 equivalent) of 2008?
Make the answer very short. 1548.9. What is the difference between the highest and the lowest SF6 emissions (in thousand metric tons of CO2 equivalent) of 1990?
Your response must be concise. 1.42e+04. What is the difference between the highest and the lowest SF6 emissions (in thousand metric tons of CO2 equivalent) in 2000?
Offer a terse response. 6978.4. What is the difference between the highest and the lowest SF6 emissions (in thousand metric tons of CO2 equivalent) in 2005?
Your response must be concise. 4335.4. What is the difference between the highest and the lowest SF6 emissions (in thousand metric tons of CO2 equivalent) of 2008?
Offer a terse response. 5600.1. 